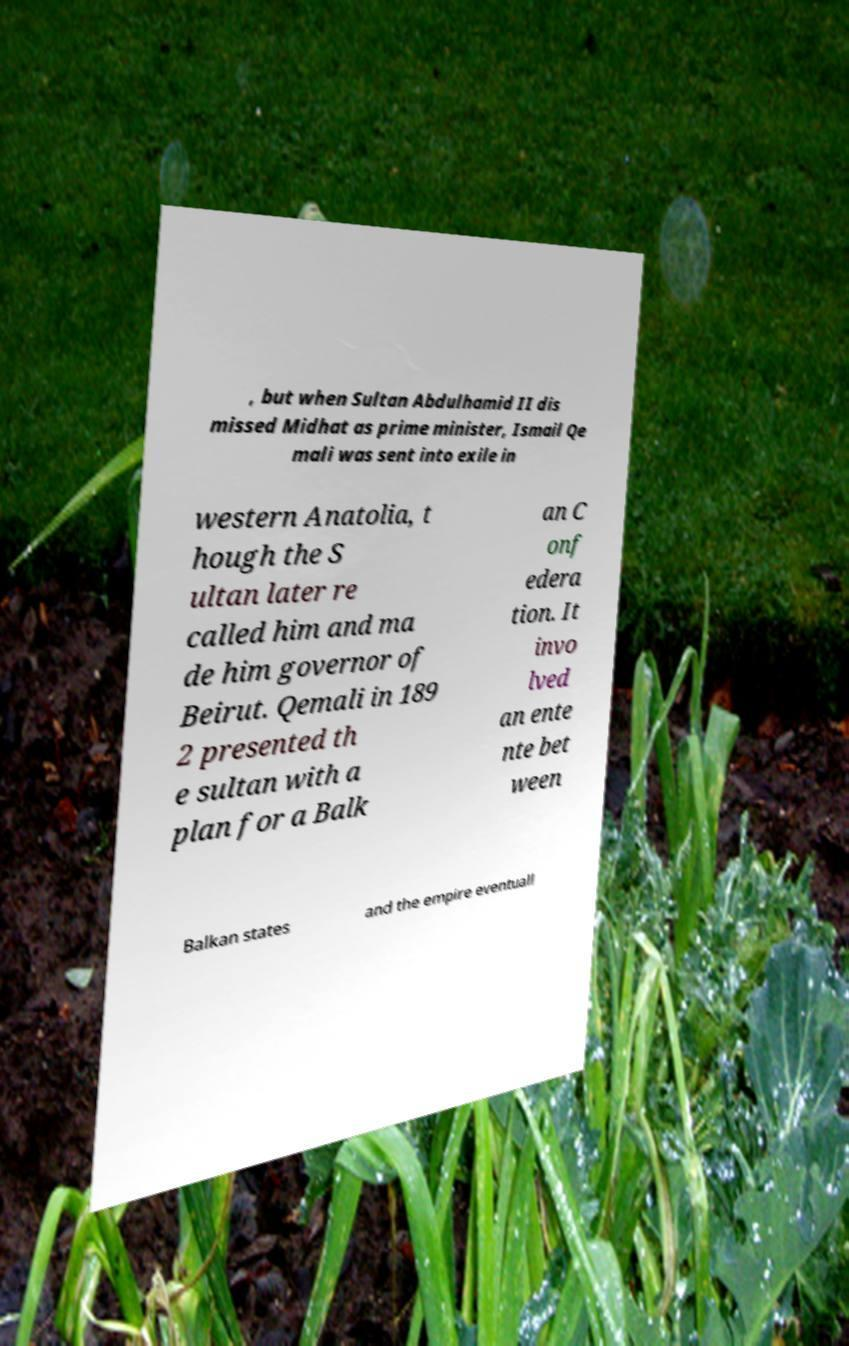What messages or text are displayed in this image? I need them in a readable, typed format. , but when Sultan Abdulhamid II dis missed Midhat as prime minister, Ismail Qe mali was sent into exile in western Anatolia, t hough the S ultan later re called him and ma de him governor of Beirut. Qemali in 189 2 presented th e sultan with a plan for a Balk an C onf edera tion. It invo lved an ente nte bet ween Balkan states and the empire eventuall 